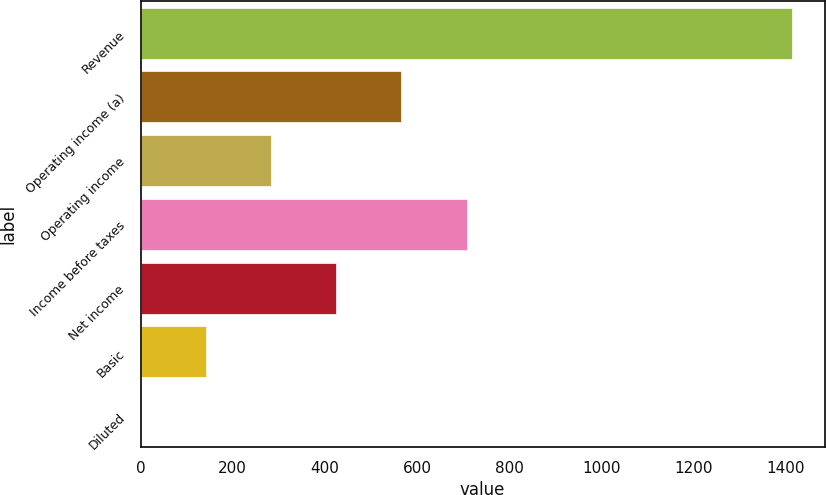Convert chart. <chart><loc_0><loc_0><loc_500><loc_500><bar_chart><fcel>Revenue<fcel>Operating income (a)<fcel>Operating income<fcel>Income before taxes<fcel>Net income<fcel>Basic<fcel>Diluted<nl><fcel>1414.2<fcel>566.27<fcel>283.63<fcel>707.59<fcel>424.95<fcel>142.31<fcel>0.99<nl></chart> 